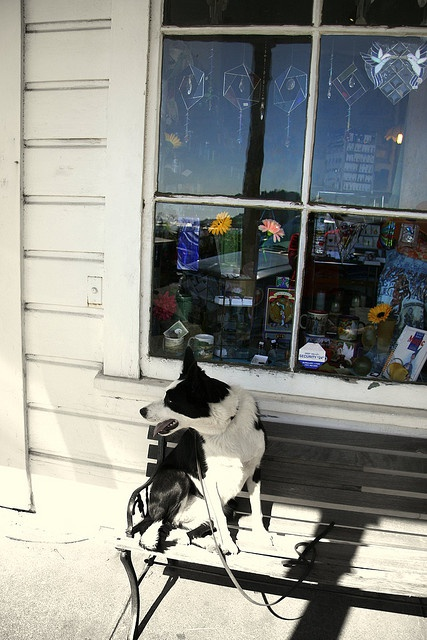Describe the objects in this image and their specific colors. I can see bench in darkgray, black, ivory, and gray tones, dog in darkgray, black, ivory, and gray tones, vase in darkgray, teal, black, darkgreen, and purple tones, cup in darkgray, black, gray, and darkblue tones, and cup in darkgray, black, and gray tones in this image. 